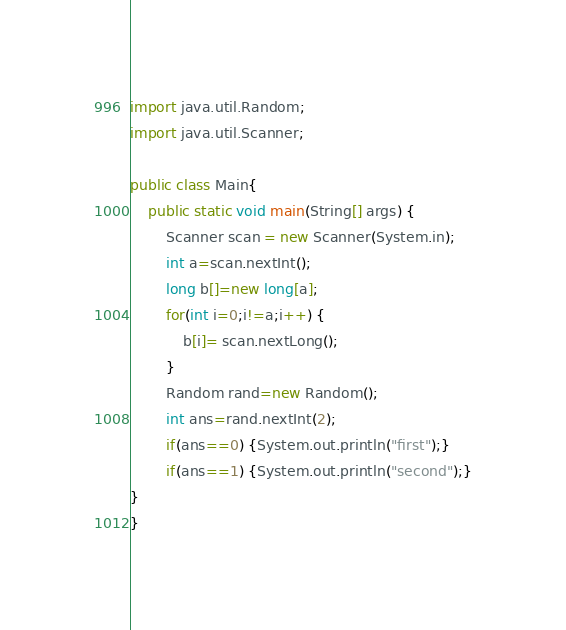Convert code to text. <code><loc_0><loc_0><loc_500><loc_500><_Java_>import java.util.Random;
import java.util.Scanner;

public class Main{
	public static void main(String[] args) {
		Scanner scan = new Scanner(System.in);
		int a=scan.nextInt();
		long b[]=new long[a];
		for(int i=0;i!=a;i++) {
			b[i]= scan.nextLong();
		}
		Random rand=new Random();
		int ans=rand.nextInt(2);
		if(ans==0) {System.out.println("first");}
		if(ans==1) {System.out.println("second");}
}
}</code> 